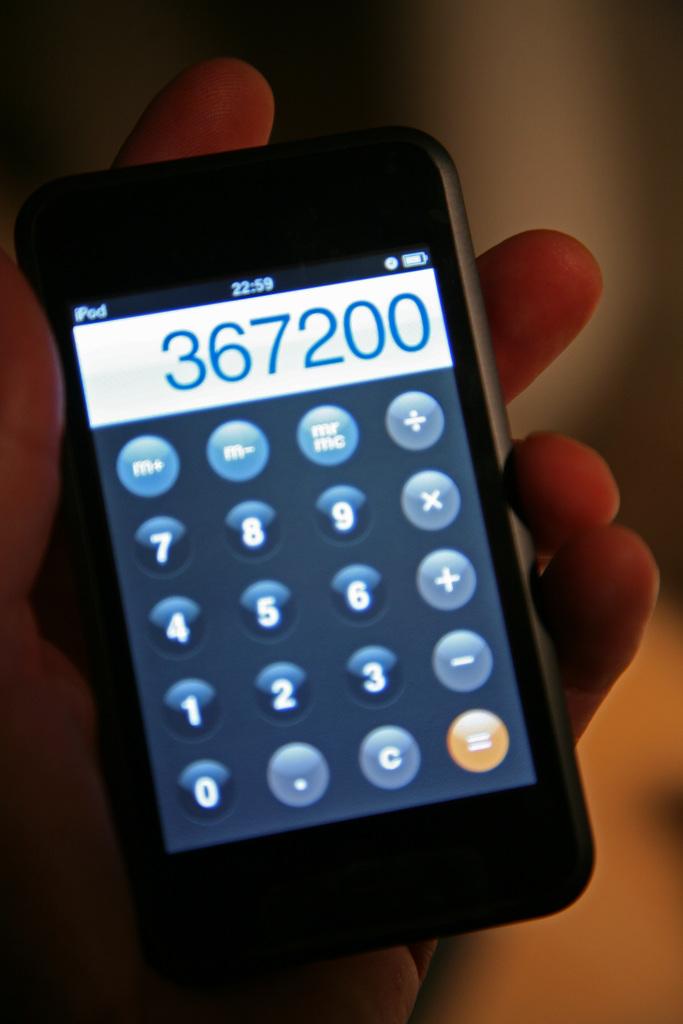What is the time on the screen?
Provide a succinct answer. 22:59. 